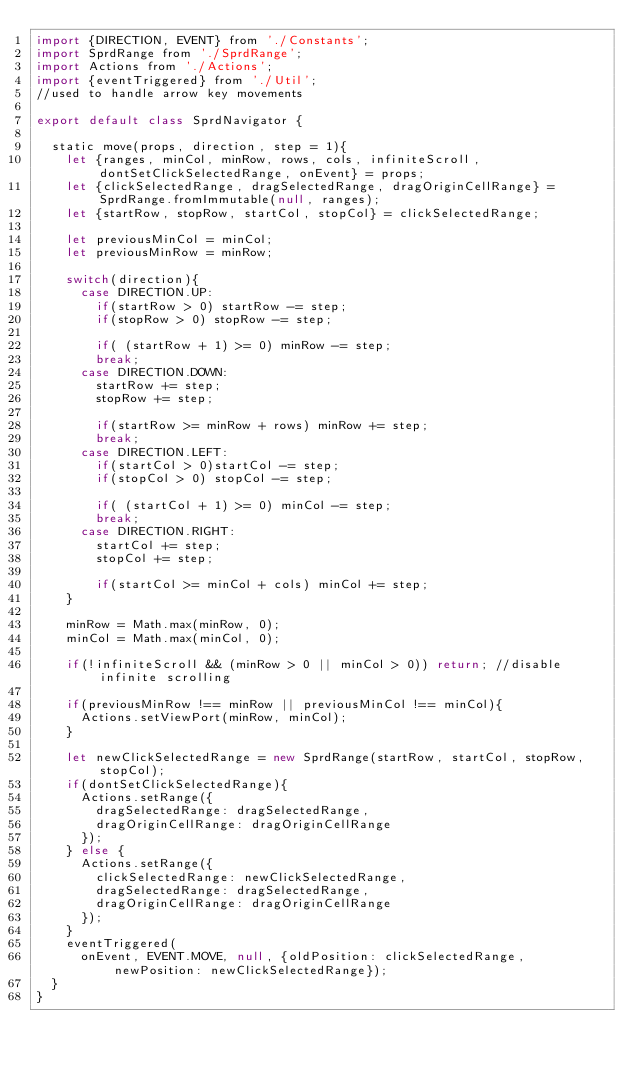<code> <loc_0><loc_0><loc_500><loc_500><_JavaScript_>import {DIRECTION, EVENT} from './Constants';
import SprdRange from './SprdRange';
import Actions from './Actions';
import {eventTriggered} from './Util';
//used to handle arrow key movements

export default class SprdNavigator {

  static move(props, direction, step = 1){
    let {ranges, minCol, minRow, rows, cols, infiniteScroll, dontSetClickSelectedRange, onEvent} = props;
    let {clickSelectedRange, dragSelectedRange, dragOriginCellRange} = SprdRange.fromImmutable(null, ranges);
    let {startRow, stopRow, startCol, stopCol} = clickSelectedRange;
    
    let previousMinCol = minCol;
    let previousMinRow = minRow;

    switch(direction){
      case DIRECTION.UP:
        if(startRow > 0) startRow -= step;
        if(stopRow > 0) stopRow -= step;

        if( (startRow + 1) >= 0) minRow -= step;
        break;
      case DIRECTION.DOWN:
        startRow += step;
        stopRow += step;

        if(startRow >= minRow + rows) minRow += step;
        break;
      case DIRECTION.LEFT:
        if(startCol > 0)startCol -= step;
        if(stopCol > 0) stopCol -= step;

        if( (startCol + 1) >= 0) minCol -= step;
        break;
      case DIRECTION.RIGHT:
        startCol += step;
        stopCol += step;

        if(startCol >= minCol + cols) minCol += step;
    }

    minRow = Math.max(minRow, 0);
    minCol = Math.max(minCol, 0);

    if(!infiniteScroll && (minRow > 0 || minCol > 0)) return; //disable infinite scrolling

    if(previousMinRow !== minRow || previousMinCol !== minCol){
      Actions.setViewPort(minRow, minCol);
    }

    let newClickSelectedRange = new SprdRange(startRow, startCol, stopRow, stopCol);
    if(dontSetClickSelectedRange){
      Actions.setRange({
        dragSelectedRange: dragSelectedRange, 
        dragOriginCellRange: dragOriginCellRange
      });
    } else {
      Actions.setRange({
        clickSelectedRange: newClickSelectedRange, 
        dragSelectedRange: dragSelectedRange, 
        dragOriginCellRange: dragOriginCellRange
      });
    }
    eventTriggered(
      onEvent, EVENT.MOVE, null, {oldPosition: clickSelectedRange, newPosition: newClickSelectedRange});
  }
}</code> 